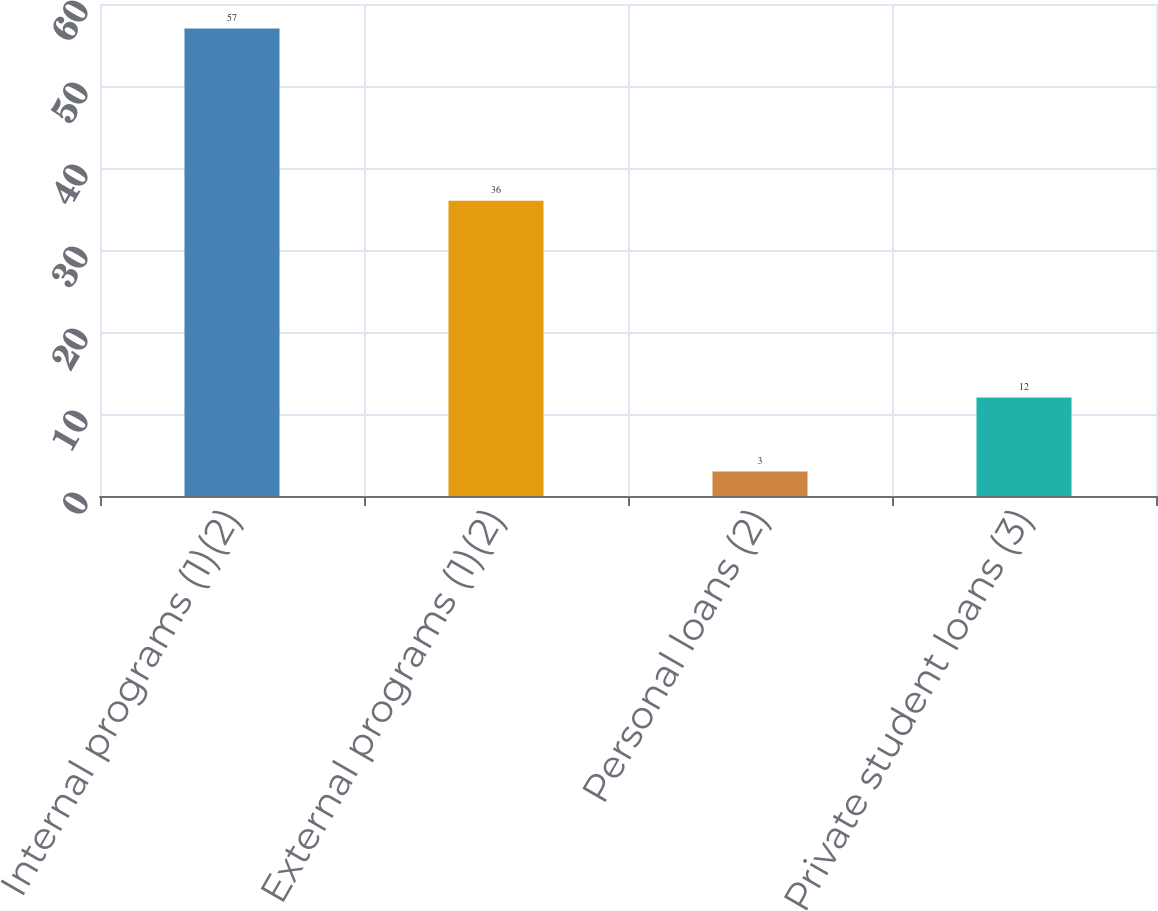Convert chart to OTSL. <chart><loc_0><loc_0><loc_500><loc_500><bar_chart><fcel>Internal programs (1)(2)<fcel>External programs (1)(2)<fcel>Personal loans (2)<fcel>Private student loans (3)<nl><fcel>57<fcel>36<fcel>3<fcel>12<nl></chart> 